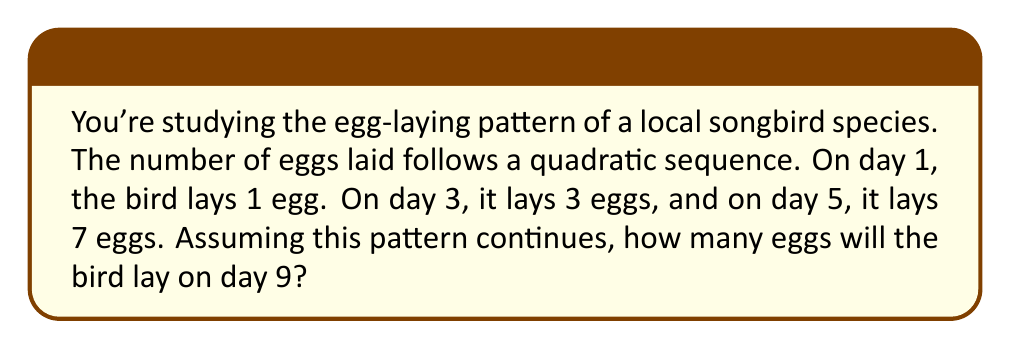Provide a solution to this math problem. Let's approach this step-by-step:

1) We're told that the sequence is quadratic, so it will have the general form:
   $a_n = an^2 + bn + c$, where $n$ is the day number.

2) We have three data points:
   Day 1: 1 egg
   Day 3: 3 eggs
   Day 5: 7 eggs

3) Let's substitute these into our general form:
   $1 = a(1)^2 + b(1) + c$
   $3 = a(3)^2 + b(3) + c$
   $7 = a(5)^2 + b(5) + c$

4) Simplify:
   $1 = a + b + c$
   $3 = 9a + 3b + c$
   $7 = 25a + 5b + c$

5) Subtract the first equation from the second:
   $2 = 8a + 2b$
   $1 = 4a + b$

6) Subtract the second equation from the third:
   $4 = 16a + 2b$
   $2 = 8a + b$

7) Subtract twice the equation in step 5 from the equation in step 6:
   $0 = 0a - b$
   $b = 0$

8) Substitute this back into the equation from step 5:
   $1 = 4a + 0$
   $a = \frac{1}{4}$

9) Substitute these values into the first equation from step 4:
   $1 = \frac{1}{4} + 0 + c$
   $c = \frac{3}{4}$

10) So our quadratic sequence is:
    $a_n = \frac{1}{4}n^2 + \frac{3}{4}$

11) To find the number of eggs on day 9, substitute $n = 9$:
    $a_9 = \frac{1}{4}(9)^2 + \frac{3}{4} = \frac{81}{4} + \frac{3}{4} = 21$

Therefore, on day 9, the bird will lay 21 eggs.
Answer: 21 eggs 